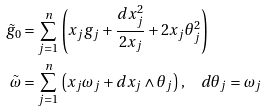Convert formula to latex. <formula><loc_0><loc_0><loc_500><loc_500>\tilde { g } _ { 0 } & = \sum _ { j = 1 } ^ { n } \left ( x _ { j } g _ { j } + \frac { d x _ { j } ^ { 2 } } { 2 x _ { j } } + 2 x _ { j } \theta _ { j } ^ { 2 } \right ) \\ \tilde { \omega } & = \sum _ { j = 1 } ^ { n } \left ( x _ { j } \omega _ { j } + d x _ { j } \wedge \theta _ { j } \right ) , \quad d \theta _ { j } = \omega _ { j }</formula> 